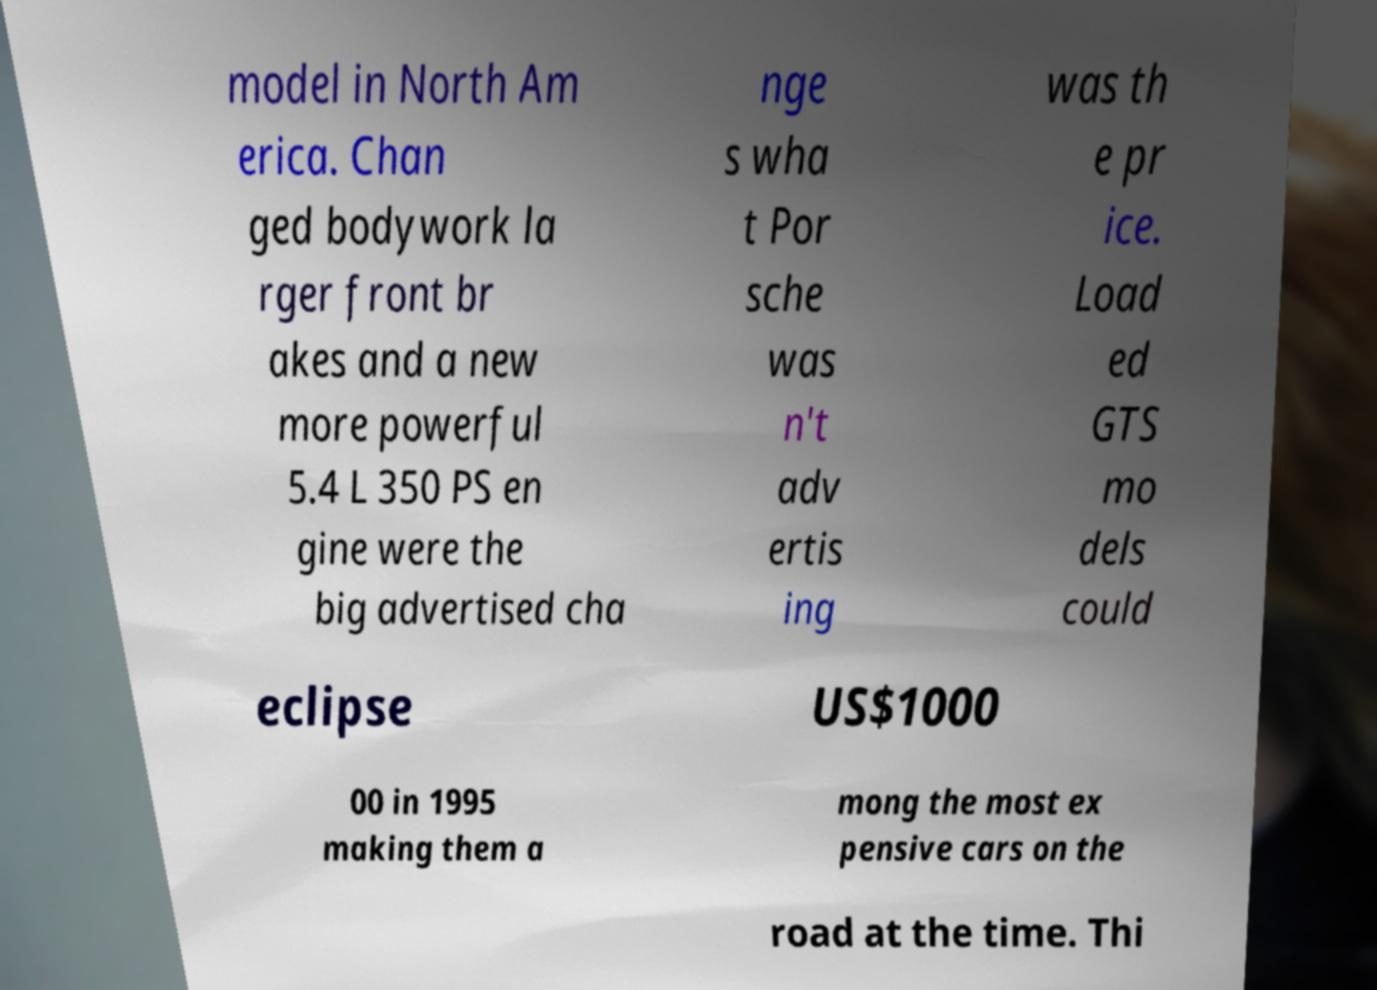Please read and relay the text visible in this image. What does it say? model in North Am erica. Chan ged bodywork la rger front br akes and a new more powerful 5.4 L 350 PS en gine were the big advertised cha nge s wha t Por sche was n't adv ertis ing was th e pr ice. Load ed GTS mo dels could eclipse US$1000 00 in 1995 making them a mong the most ex pensive cars on the road at the time. Thi 